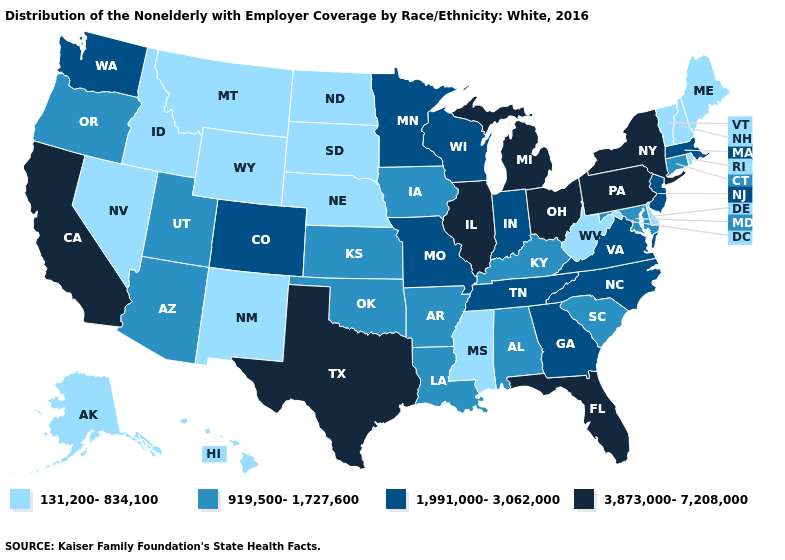Does Missouri have the highest value in the USA?
Keep it brief. No. Does Connecticut have a higher value than Maine?
Keep it brief. Yes. What is the value of Idaho?
Quick response, please. 131,200-834,100. What is the value of Nebraska?
Be succinct. 131,200-834,100. Is the legend a continuous bar?
Write a very short answer. No. What is the lowest value in the USA?
Give a very brief answer. 131,200-834,100. What is the value of Montana?
Be succinct. 131,200-834,100. Name the states that have a value in the range 131,200-834,100?
Write a very short answer. Alaska, Delaware, Hawaii, Idaho, Maine, Mississippi, Montana, Nebraska, Nevada, New Hampshire, New Mexico, North Dakota, Rhode Island, South Dakota, Vermont, West Virginia, Wyoming. What is the highest value in states that border Rhode Island?
Keep it brief. 1,991,000-3,062,000. Does Arizona have the lowest value in the West?
Keep it brief. No. What is the value of New York?
Quick response, please. 3,873,000-7,208,000. What is the value of New Jersey?
Give a very brief answer. 1,991,000-3,062,000. What is the value of Michigan?
Keep it brief. 3,873,000-7,208,000. What is the value of Colorado?
Quick response, please. 1,991,000-3,062,000. Name the states that have a value in the range 131,200-834,100?
Keep it brief. Alaska, Delaware, Hawaii, Idaho, Maine, Mississippi, Montana, Nebraska, Nevada, New Hampshire, New Mexico, North Dakota, Rhode Island, South Dakota, Vermont, West Virginia, Wyoming. 